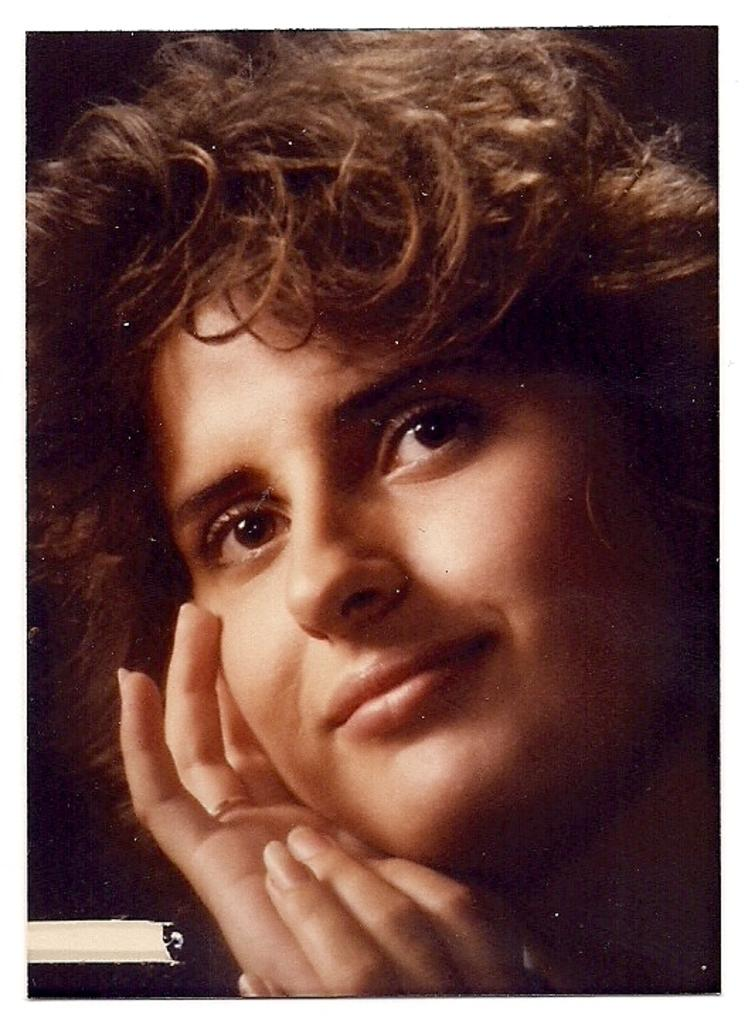What is the main subject of the image? There is a woman's face in the image. Can you describe any specific features of the woman's face? Unfortunately, the provided facts do not include any specific details about the woman's face. Is there any text or writing present in the image? The facts do not mention any text or writing in the image. What type of receipt is visible in the woman's hand in the image? There is no receipt present in the image, as the facts only mention a woman's face. Can you tell me how the woman is using the spade in the image? There is no spade present in the image, as the facts only mention a woman's face. 